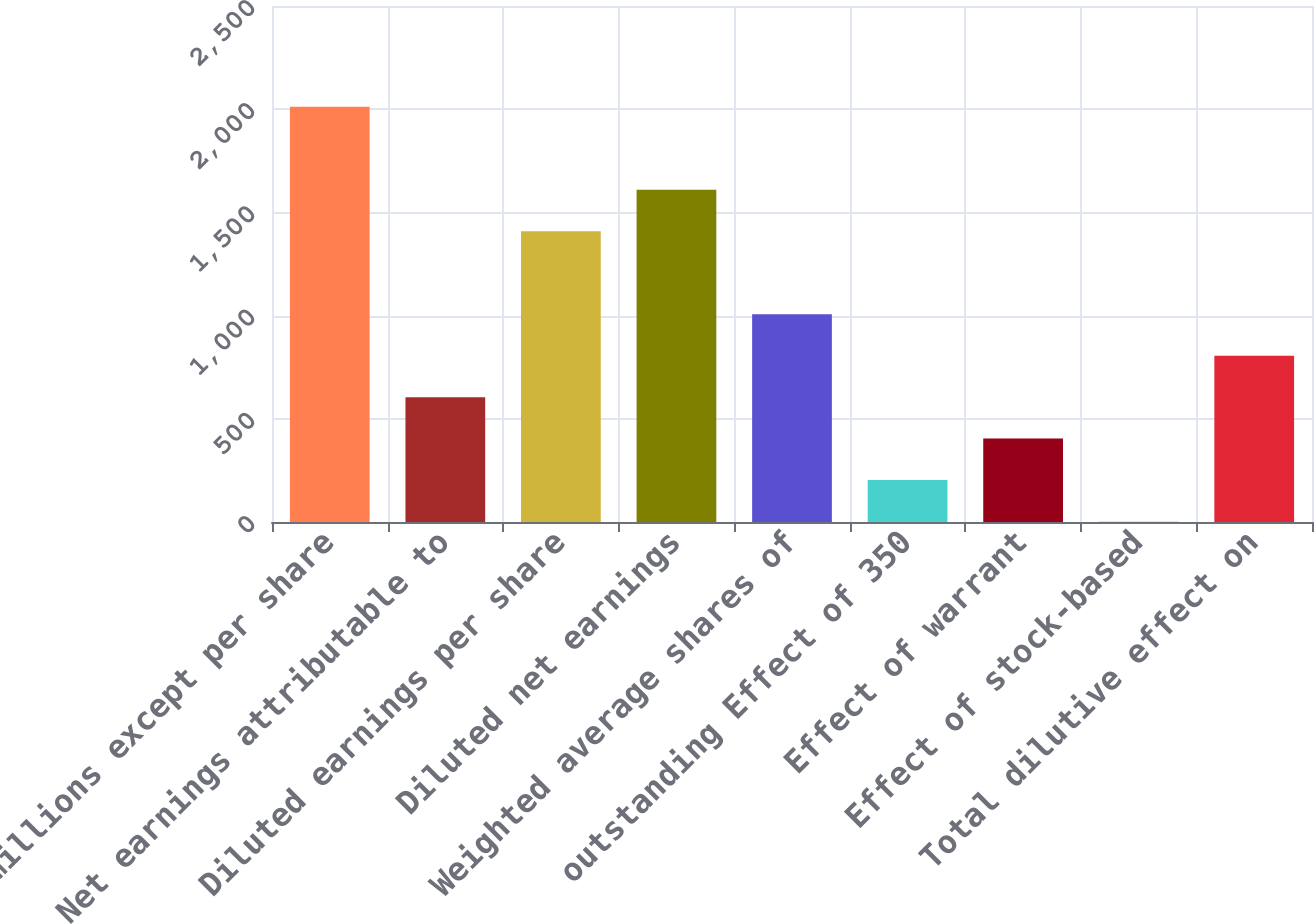Convert chart. <chart><loc_0><loc_0><loc_500><loc_500><bar_chart><fcel>(in millions except per share<fcel>Net earnings attributable to<fcel>Diluted earnings per share<fcel>Diluted net earnings<fcel>Weighted average shares of<fcel>outstanding Effect of 350<fcel>Effect of warrant<fcel>Effect of stock-based<fcel>Total dilutive effect on<nl><fcel>2012<fcel>605<fcel>1409<fcel>1610<fcel>1007<fcel>203<fcel>404<fcel>2<fcel>806<nl></chart> 